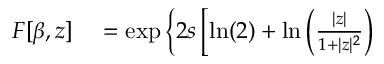Convert formula to latex. <formula><loc_0><loc_0><loc_500><loc_500>\begin{array} { r l } { F [ \beta , z ] } & = \exp \left \{ 2 s \left [ \ln ( 2 ) + \ln \left ( \frac { | z | } { 1 + | z | ^ { 2 } } \right ) } \end{array}</formula> 